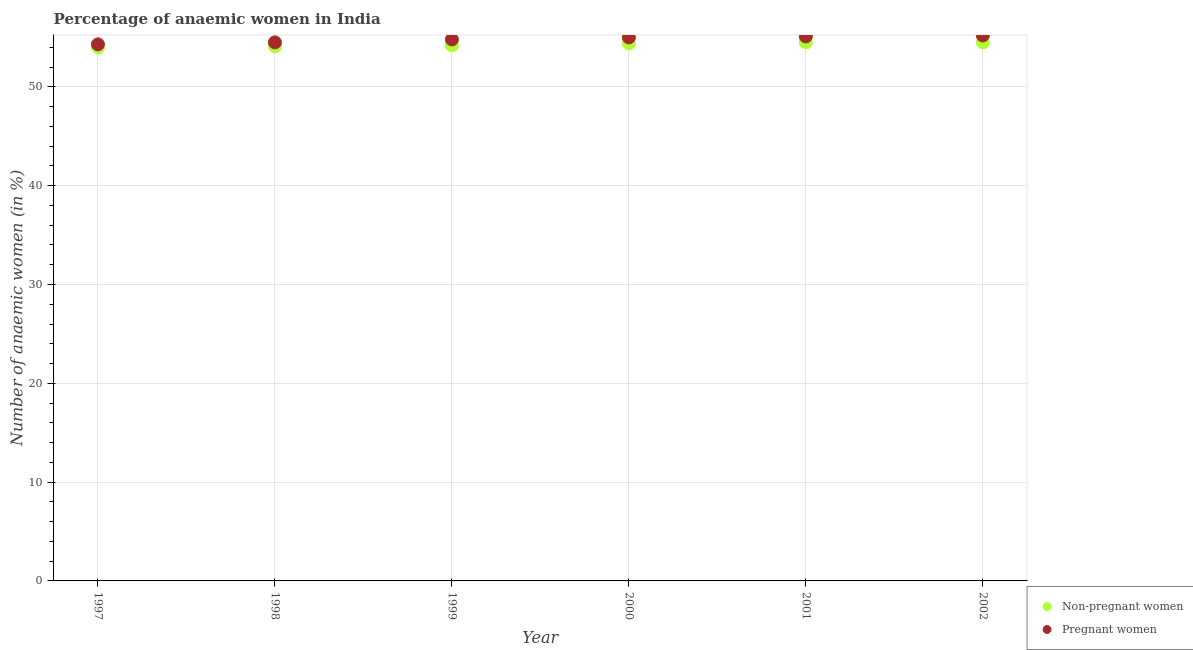What is the percentage of pregnant anaemic women in 2001?
Provide a short and direct response. 55.1. Across all years, what is the maximum percentage of pregnant anaemic women?
Your answer should be very brief. 55.2. Across all years, what is the minimum percentage of non-pregnant anaemic women?
Your answer should be very brief. 54. What is the total percentage of pregnant anaemic women in the graph?
Offer a terse response. 328.9. What is the difference between the percentage of non-pregnant anaemic women in 1997 and that in 2002?
Make the answer very short. -0.5. What is the difference between the percentage of non-pregnant anaemic women in 1997 and the percentage of pregnant anaemic women in 2002?
Your answer should be very brief. -1.2. What is the average percentage of non-pregnant anaemic women per year?
Make the answer very short. 54.28. In the year 1999, what is the difference between the percentage of pregnant anaemic women and percentage of non-pregnant anaemic women?
Ensure brevity in your answer.  0.6. In how many years, is the percentage of non-pregnant anaemic women greater than 40 %?
Make the answer very short. 6. What is the ratio of the percentage of pregnant anaemic women in 1997 to that in 1998?
Make the answer very short. 1. Is the percentage of pregnant anaemic women in 1999 less than that in 2002?
Your answer should be very brief. Yes. Is the difference between the percentage of non-pregnant anaemic women in 2001 and 2002 greater than the difference between the percentage of pregnant anaemic women in 2001 and 2002?
Offer a very short reply. Yes. What is the difference between the highest and the second highest percentage of pregnant anaemic women?
Offer a very short reply. 0.1. What is the difference between the highest and the lowest percentage of pregnant anaemic women?
Your answer should be very brief. 0.9. In how many years, is the percentage of pregnant anaemic women greater than the average percentage of pregnant anaemic women taken over all years?
Ensure brevity in your answer.  3. Is the sum of the percentage of non-pregnant anaemic women in 1997 and 2002 greater than the maximum percentage of pregnant anaemic women across all years?
Keep it short and to the point. Yes. Is the percentage of pregnant anaemic women strictly greater than the percentage of non-pregnant anaemic women over the years?
Provide a succinct answer. Yes. How many legend labels are there?
Make the answer very short. 2. What is the title of the graph?
Provide a short and direct response. Percentage of anaemic women in India. Does "Manufacturing industries and construction" appear as one of the legend labels in the graph?
Make the answer very short. No. What is the label or title of the Y-axis?
Keep it short and to the point. Number of anaemic women (in %). What is the Number of anaemic women (in %) of Pregnant women in 1997?
Offer a very short reply. 54.3. What is the Number of anaemic women (in %) of Non-pregnant women in 1998?
Your answer should be compact. 54.1. What is the Number of anaemic women (in %) in Pregnant women in 1998?
Provide a succinct answer. 54.5. What is the Number of anaemic women (in %) in Non-pregnant women in 1999?
Offer a very short reply. 54.2. What is the Number of anaemic women (in %) of Pregnant women in 1999?
Your answer should be compact. 54.8. What is the Number of anaemic women (in %) in Non-pregnant women in 2000?
Make the answer very short. 54.4. What is the Number of anaemic women (in %) in Non-pregnant women in 2001?
Your response must be concise. 54.5. What is the Number of anaemic women (in %) in Pregnant women in 2001?
Your answer should be compact. 55.1. What is the Number of anaemic women (in %) in Non-pregnant women in 2002?
Make the answer very short. 54.5. What is the Number of anaemic women (in %) in Pregnant women in 2002?
Offer a very short reply. 55.2. Across all years, what is the maximum Number of anaemic women (in %) of Non-pregnant women?
Offer a terse response. 54.5. Across all years, what is the maximum Number of anaemic women (in %) in Pregnant women?
Give a very brief answer. 55.2. Across all years, what is the minimum Number of anaemic women (in %) in Non-pregnant women?
Offer a terse response. 54. Across all years, what is the minimum Number of anaemic women (in %) of Pregnant women?
Give a very brief answer. 54.3. What is the total Number of anaemic women (in %) of Non-pregnant women in the graph?
Ensure brevity in your answer.  325.7. What is the total Number of anaemic women (in %) in Pregnant women in the graph?
Give a very brief answer. 328.9. What is the difference between the Number of anaemic women (in %) of Pregnant women in 1997 and that in 1998?
Your answer should be very brief. -0.2. What is the difference between the Number of anaemic women (in %) of Non-pregnant women in 1997 and that in 1999?
Keep it short and to the point. -0.2. What is the difference between the Number of anaemic women (in %) in Pregnant women in 1997 and that in 1999?
Your answer should be compact. -0.5. What is the difference between the Number of anaemic women (in %) of Non-pregnant women in 1997 and that in 2000?
Offer a terse response. -0.4. What is the difference between the Number of anaemic women (in %) of Non-pregnant women in 1997 and that in 2001?
Keep it short and to the point. -0.5. What is the difference between the Number of anaemic women (in %) of Pregnant women in 1997 and that in 2001?
Offer a very short reply. -0.8. What is the difference between the Number of anaemic women (in %) of Non-pregnant women in 1997 and that in 2002?
Offer a terse response. -0.5. What is the difference between the Number of anaemic women (in %) of Pregnant women in 1997 and that in 2002?
Offer a very short reply. -0.9. What is the difference between the Number of anaemic women (in %) in Pregnant women in 1998 and that in 1999?
Your response must be concise. -0.3. What is the difference between the Number of anaemic women (in %) of Non-pregnant women in 1998 and that in 2000?
Your answer should be compact. -0.3. What is the difference between the Number of anaemic women (in %) of Non-pregnant women in 1998 and that in 2001?
Your response must be concise. -0.4. What is the difference between the Number of anaemic women (in %) of Pregnant women in 1998 and that in 2002?
Your answer should be very brief. -0.7. What is the difference between the Number of anaemic women (in %) in Non-pregnant women in 1999 and that in 2000?
Give a very brief answer. -0.2. What is the difference between the Number of anaemic women (in %) in Non-pregnant women in 1999 and that in 2001?
Ensure brevity in your answer.  -0.3. What is the difference between the Number of anaemic women (in %) in Pregnant women in 2000 and that in 2001?
Provide a succinct answer. -0.1. What is the difference between the Number of anaemic women (in %) of Non-pregnant women in 2000 and that in 2002?
Give a very brief answer. -0.1. What is the difference between the Number of anaemic women (in %) of Pregnant women in 2001 and that in 2002?
Your answer should be very brief. -0.1. What is the difference between the Number of anaemic women (in %) of Non-pregnant women in 1997 and the Number of anaemic women (in %) of Pregnant women in 1999?
Make the answer very short. -0.8. What is the difference between the Number of anaemic women (in %) of Non-pregnant women in 1998 and the Number of anaemic women (in %) of Pregnant women in 2002?
Give a very brief answer. -1.1. What is the difference between the Number of anaemic women (in %) in Non-pregnant women in 1999 and the Number of anaemic women (in %) in Pregnant women in 2000?
Offer a terse response. -0.8. What is the difference between the Number of anaemic women (in %) in Non-pregnant women in 1999 and the Number of anaemic women (in %) in Pregnant women in 2002?
Offer a very short reply. -1. What is the difference between the Number of anaemic women (in %) of Non-pregnant women in 2000 and the Number of anaemic women (in %) of Pregnant women in 2002?
Your answer should be very brief. -0.8. What is the difference between the Number of anaemic women (in %) of Non-pregnant women in 2001 and the Number of anaemic women (in %) of Pregnant women in 2002?
Your answer should be very brief. -0.7. What is the average Number of anaemic women (in %) in Non-pregnant women per year?
Provide a succinct answer. 54.28. What is the average Number of anaemic women (in %) of Pregnant women per year?
Your answer should be very brief. 54.82. In the year 1998, what is the difference between the Number of anaemic women (in %) of Non-pregnant women and Number of anaemic women (in %) of Pregnant women?
Provide a succinct answer. -0.4. In the year 1999, what is the difference between the Number of anaemic women (in %) of Non-pregnant women and Number of anaemic women (in %) of Pregnant women?
Your answer should be compact. -0.6. In the year 2000, what is the difference between the Number of anaemic women (in %) of Non-pregnant women and Number of anaemic women (in %) of Pregnant women?
Offer a terse response. -0.6. In the year 2001, what is the difference between the Number of anaemic women (in %) of Non-pregnant women and Number of anaemic women (in %) of Pregnant women?
Your response must be concise. -0.6. In the year 2002, what is the difference between the Number of anaemic women (in %) in Non-pregnant women and Number of anaemic women (in %) in Pregnant women?
Your answer should be very brief. -0.7. What is the ratio of the Number of anaemic women (in %) in Non-pregnant women in 1997 to that in 1999?
Provide a succinct answer. 1. What is the ratio of the Number of anaemic women (in %) of Pregnant women in 1997 to that in 1999?
Your response must be concise. 0.99. What is the ratio of the Number of anaemic women (in %) in Non-pregnant women in 1997 to that in 2000?
Give a very brief answer. 0.99. What is the ratio of the Number of anaemic women (in %) of Pregnant women in 1997 to that in 2000?
Offer a very short reply. 0.99. What is the ratio of the Number of anaemic women (in %) in Non-pregnant women in 1997 to that in 2001?
Ensure brevity in your answer.  0.99. What is the ratio of the Number of anaemic women (in %) in Pregnant women in 1997 to that in 2001?
Your answer should be compact. 0.99. What is the ratio of the Number of anaemic women (in %) of Pregnant women in 1997 to that in 2002?
Ensure brevity in your answer.  0.98. What is the ratio of the Number of anaemic women (in %) in Non-pregnant women in 1998 to that in 1999?
Your answer should be very brief. 1. What is the ratio of the Number of anaemic women (in %) of Pregnant women in 1998 to that in 1999?
Your answer should be compact. 0.99. What is the ratio of the Number of anaemic women (in %) in Non-pregnant women in 1998 to that in 2000?
Your response must be concise. 0.99. What is the ratio of the Number of anaemic women (in %) in Pregnant women in 1998 to that in 2000?
Your response must be concise. 0.99. What is the ratio of the Number of anaemic women (in %) in Non-pregnant women in 1998 to that in 2001?
Your answer should be very brief. 0.99. What is the ratio of the Number of anaemic women (in %) of Non-pregnant women in 1998 to that in 2002?
Give a very brief answer. 0.99. What is the ratio of the Number of anaemic women (in %) in Pregnant women in 1998 to that in 2002?
Offer a terse response. 0.99. What is the ratio of the Number of anaemic women (in %) in Non-pregnant women in 1999 to that in 2000?
Provide a succinct answer. 1. What is the ratio of the Number of anaemic women (in %) in Pregnant women in 1999 to that in 2000?
Give a very brief answer. 1. What is the ratio of the Number of anaemic women (in %) in Non-pregnant women in 1999 to that in 2001?
Provide a short and direct response. 0.99. What is the ratio of the Number of anaemic women (in %) in Non-pregnant women in 1999 to that in 2002?
Your answer should be compact. 0.99. What is the ratio of the Number of anaemic women (in %) in Pregnant women in 1999 to that in 2002?
Keep it short and to the point. 0.99. What is the ratio of the Number of anaemic women (in %) of Pregnant women in 2000 to that in 2002?
Give a very brief answer. 1. What is the difference between the highest and the lowest Number of anaemic women (in %) of Pregnant women?
Provide a short and direct response. 0.9. 